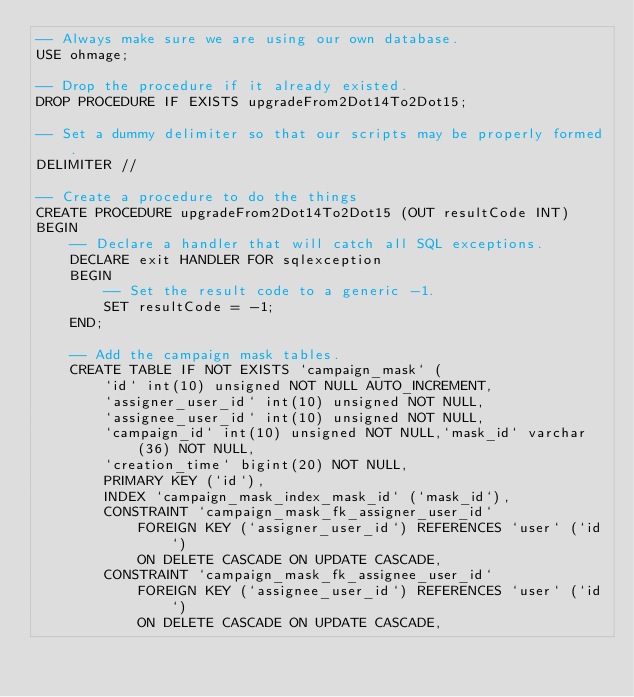Convert code to text. <code><loc_0><loc_0><loc_500><loc_500><_SQL_>-- Always make sure we are using our own database.
USE ohmage;

-- Drop the procedure if it already existed.
DROP PROCEDURE IF EXISTS upgradeFrom2Dot14To2Dot15;

-- Set a dummy delimiter so that our scripts may be properly formed.
DELIMITER //

-- Create a procedure to do the things 
CREATE PROCEDURE upgradeFrom2Dot14To2Dot15 (OUT resultCode INT)
BEGIN
    -- Declare a handler that will catch all SQL exceptions.
    DECLARE exit HANDLER FOR sqlexception
    BEGIN
        -- Set the result code to a generic -1.
        SET resultCode = -1;
    END;
    
    -- Add the campaign mask tables.
    CREATE TABLE IF NOT EXISTS `campaign_mask` (
        `id` int(10) unsigned NOT NULL AUTO_INCREMENT,
        `assigner_user_id` int(10) unsigned NOT NULL,
        `assignee_user_id` int(10) unsigned NOT NULL,
        `campaign_id` int(10) unsigned NOT NULL,`mask_id` varchar(36) NOT NULL,
        `creation_time` bigint(20) NOT NULL,
        PRIMARY KEY (`id`),
        INDEX `campaign_mask_index_mask_id` (`mask_id`),
        CONSTRAINT `campaign_mask_fk_assigner_user_id`
            FOREIGN KEY (`assigner_user_id`) REFERENCES `user` (`id`)
            ON DELETE CASCADE ON UPDATE CASCADE,
        CONSTRAINT `campaign_mask_fk_assignee_user_id`
            FOREIGN KEY (`assignee_user_id`) REFERENCES `user` (`id`)
            ON DELETE CASCADE ON UPDATE CASCADE,</code> 